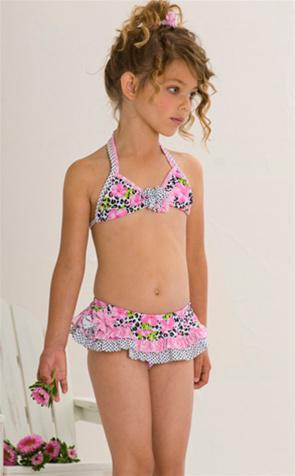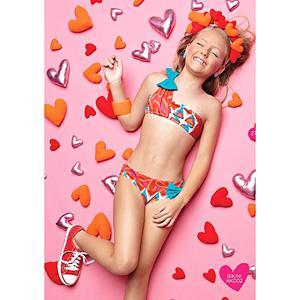The first image is the image on the left, the second image is the image on the right. Examine the images to the left and right. Is the description "A girl is laying down in colorful hearts" accurate? Answer yes or no. Yes. 